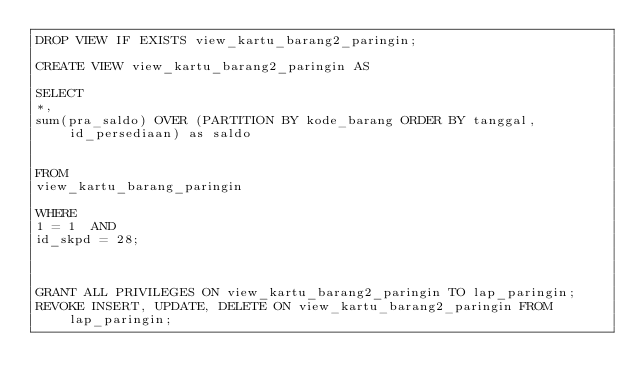Convert code to text. <code><loc_0><loc_0><loc_500><loc_500><_SQL_>DROP VIEW IF EXISTS view_kartu_barang2_paringin;

CREATE VIEW view_kartu_barang2_paringin AS

SELECT
*,
sum(pra_saldo) OVER (PARTITION BY kode_barang ORDER BY tanggal, id_persediaan) as saldo


FROM
view_kartu_barang_paringin

WHERE
1 = 1  AND
id_skpd = 28;



GRANT ALL PRIVILEGES ON view_kartu_barang2_paringin TO lap_paringin;
REVOKE INSERT, UPDATE, DELETE ON view_kartu_barang2_paringin FROM lap_paringin;
</code> 